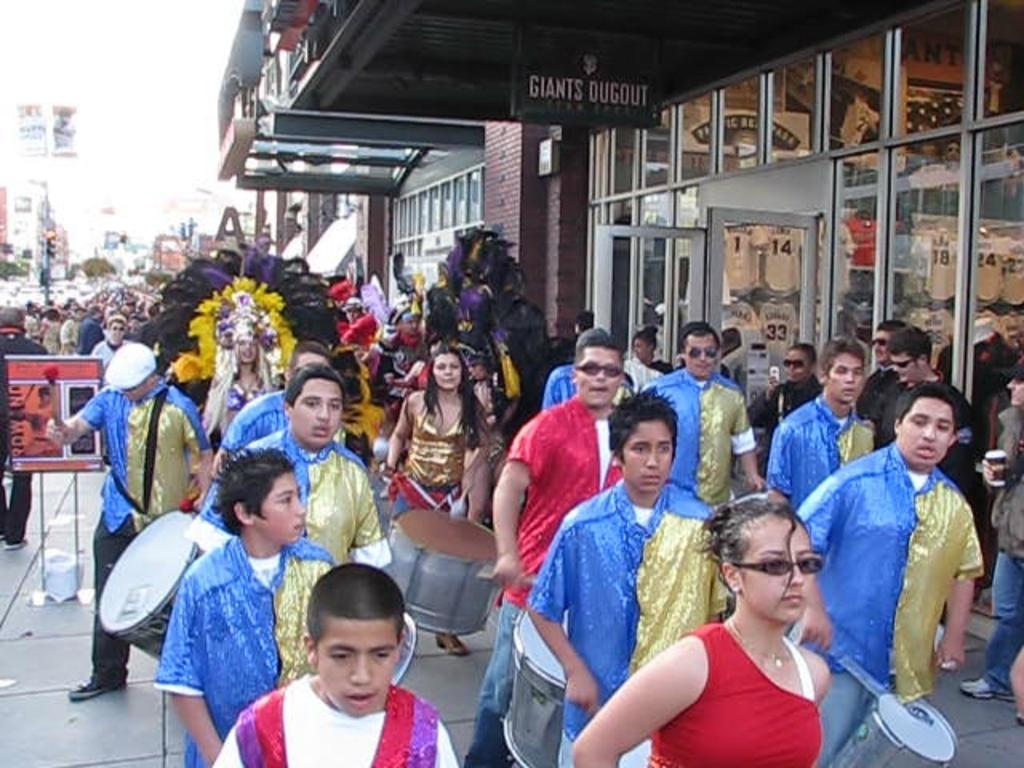What is the main subject of the image? The main subject of the image is a group of people standing together. How can the group of people be described? The group of people can be referred to as a crowd. What type of buildings can be seen in the image? There are buildings with glass in the image. Can you describe the attire of one of the people in the image? There is a person wearing a fancy dress in the image. What objects are being carried by some people in the image? Some people are carrying drums in the image. What type of trees can be seen in the image? There are no trees visible in the image; it features a group of people, buildings with glass, and people carrying drums. 